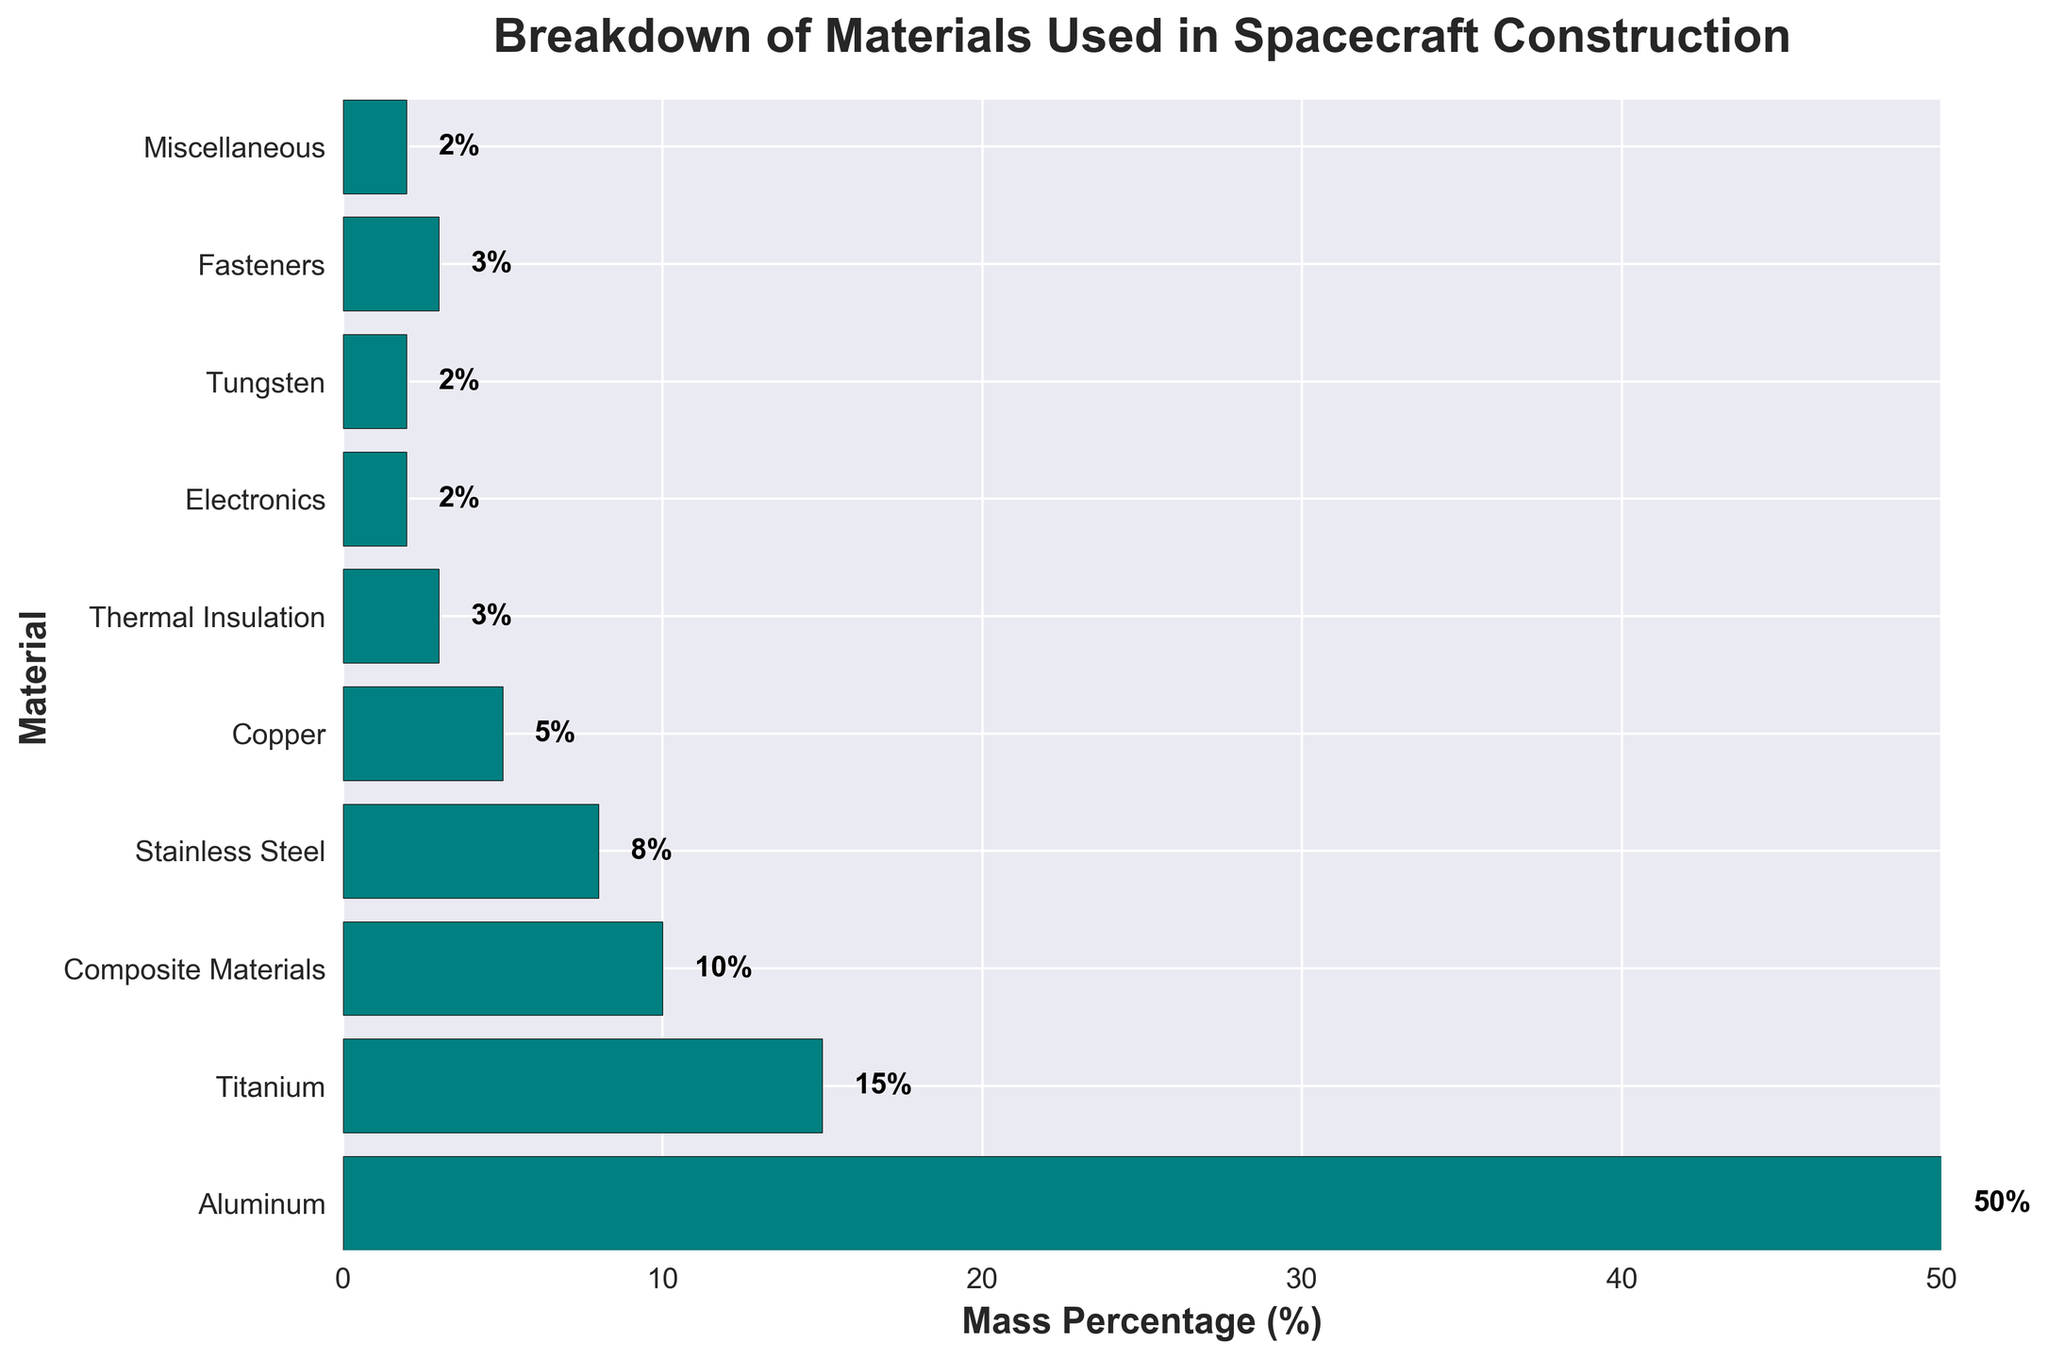Which material has the highest mass percentage? The bar chart shows that Aluminum has the longest bar. The percentage label next to the bar indicates it is 50%.
Answer: Aluminum What is the combined mass percentage of Copper and Thermal Insulation? According to the chart, Copper has 5% and Thermal Insulation has 3%. Adding these together: 5% + 3% = 8%.
Answer: 8% How does the mass percentage of Titanium compare with Stainless Steel? The bar chart shows Titanium with a mass percentage of 15% and Stainless Steel with 8%. Titanium has a higher mass percentage.
Answer: Titanium has a higher mass percentage What is the difference in mass percentage between Composite Materials and Miscellaneous? Composite Materials have a mass percentage of 10%, while Miscellaneous has 2%. The difference is 10% - 2% = 8%.
Answer: 8% Which materials have an equal mass percentage? According to the bar chart, Electronics, Tungsten, and Miscellaneous each have a mass percentage of 2%.
Answer: Electronics, Tungsten, and Miscellaneous What is the total mass percentage of all materials except Aluminum? First, subtract the mass percentage of Aluminum from 100%: 100% - 50% = 50%.
Answer: 50% How many materials have a mass percentage greater than or equal to 10%? Referring to the bar chart, the materials with mass percentages ≥ 10% are Aluminum (50%), Titanium (15%), and Composite Materials (10%). There are 3 such materials.
Answer: 3 Which material corresponds to the shortest bar in the bar chart? The shortest bar in the chart corresponds to Electronics, Tungsten, and Miscellaneous, each with a mass percentage of 2%.
Answer: Electronics, Tungsten, and Miscellaneous What is the combined mass percentage of the materials used in insulation and fasteners? Thermal Insulation has 3% and Fasteners have 3%. Adding these together: 3% + 3% = 6%.
Answer: 6% Is the mass percentage of Copper greater than that of Fasteners? The chart shows Copper at 5% and Fasteners at 3%. Copper's mass percentage is greater.
Answer: Yes 